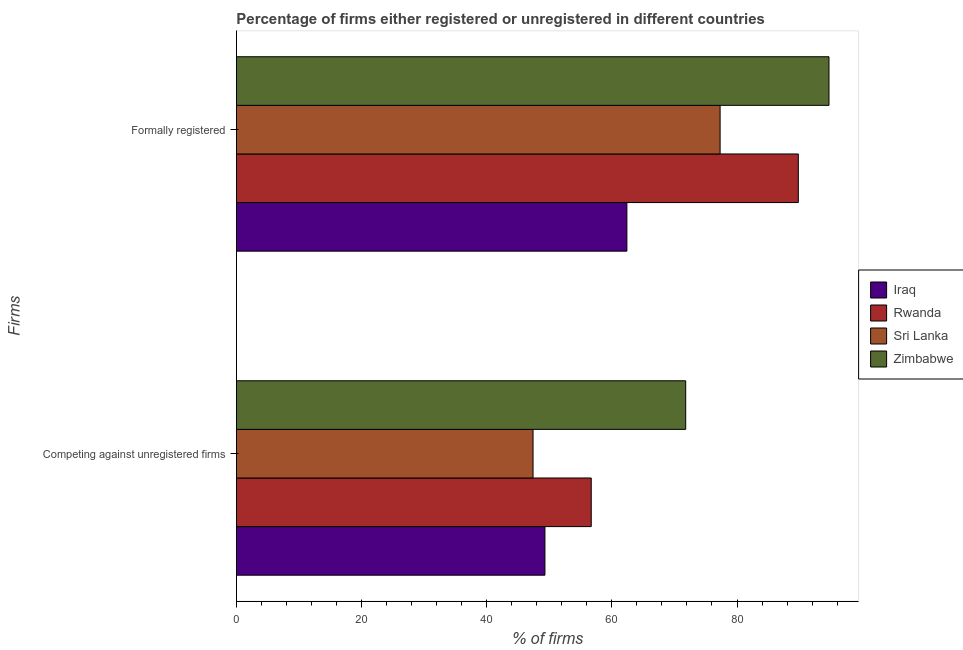How many different coloured bars are there?
Provide a succinct answer. 4. Are the number of bars on each tick of the Y-axis equal?
Your response must be concise. Yes. How many bars are there on the 1st tick from the top?
Your response must be concise. 4. What is the label of the 1st group of bars from the top?
Ensure brevity in your answer.  Formally registered. What is the percentage of formally registered firms in Sri Lanka?
Your answer should be compact. 77.3. Across all countries, what is the maximum percentage of registered firms?
Keep it short and to the point. 71.8. Across all countries, what is the minimum percentage of formally registered firms?
Offer a very short reply. 62.4. In which country was the percentage of formally registered firms maximum?
Make the answer very short. Zimbabwe. In which country was the percentage of formally registered firms minimum?
Make the answer very short. Iraq. What is the total percentage of registered firms in the graph?
Keep it short and to the point. 225.2. What is the difference between the percentage of registered firms in Zimbabwe and that in Rwanda?
Make the answer very short. 15.1. What is the difference between the percentage of registered firms in Rwanda and the percentage of formally registered firms in Zimbabwe?
Your answer should be very brief. -38. What is the average percentage of registered firms per country?
Your response must be concise. 56.3. What is the difference between the percentage of registered firms and percentage of formally registered firms in Sri Lanka?
Offer a very short reply. -29.9. What is the ratio of the percentage of registered firms in Zimbabwe to that in Iraq?
Offer a terse response. 1.46. What does the 3rd bar from the top in Formally registered represents?
Make the answer very short. Rwanda. What does the 2nd bar from the bottom in Competing against unregistered firms represents?
Your response must be concise. Rwanda. How many countries are there in the graph?
Offer a very short reply. 4. Does the graph contain any zero values?
Provide a succinct answer. No. Does the graph contain grids?
Ensure brevity in your answer.  No. How many legend labels are there?
Offer a terse response. 4. How are the legend labels stacked?
Offer a terse response. Vertical. What is the title of the graph?
Provide a succinct answer. Percentage of firms either registered or unregistered in different countries. Does "Bulgaria" appear as one of the legend labels in the graph?
Give a very brief answer. No. What is the label or title of the X-axis?
Your response must be concise. % of firms. What is the label or title of the Y-axis?
Keep it short and to the point. Firms. What is the % of firms in Iraq in Competing against unregistered firms?
Ensure brevity in your answer.  49.3. What is the % of firms in Rwanda in Competing against unregistered firms?
Ensure brevity in your answer.  56.7. What is the % of firms in Sri Lanka in Competing against unregistered firms?
Give a very brief answer. 47.4. What is the % of firms of Zimbabwe in Competing against unregistered firms?
Offer a very short reply. 71.8. What is the % of firms of Iraq in Formally registered?
Ensure brevity in your answer.  62.4. What is the % of firms in Rwanda in Formally registered?
Your response must be concise. 89.8. What is the % of firms in Sri Lanka in Formally registered?
Provide a short and direct response. 77.3. What is the % of firms in Zimbabwe in Formally registered?
Keep it short and to the point. 94.7. Across all Firms, what is the maximum % of firms in Iraq?
Offer a very short reply. 62.4. Across all Firms, what is the maximum % of firms in Rwanda?
Make the answer very short. 89.8. Across all Firms, what is the maximum % of firms of Sri Lanka?
Give a very brief answer. 77.3. Across all Firms, what is the maximum % of firms in Zimbabwe?
Your response must be concise. 94.7. Across all Firms, what is the minimum % of firms of Iraq?
Provide a short and direct response. 49.3. Across all Firms, what is the minimum % of firms in Rwanda?
Your answer should be very brief. 56.7. Across all Firms, what is the minimum % of firms of Sri Lanka?
Your response must be concise. 47.4. Across all Firms, what is the minimum % of firms of Zimbabwe?
Provide a succinct answer. 71.8. What is the total % of firms of Iraq in the graph?
Give a very brief answer. 111.7. What is the total % of firms in Rwanda in the graph?
Offer a very short reply. 146.5. What is the total % of firms in Sri Lanka in the graph?
Provide a succinct answer. 124.7. What is the total % of firms in Zimbabwe in the graph?
Provide a succinct answer. 166.5. What is the difference between the % of firms in Iraq in Competing against unregistered firms and that in Formally registered?
Make the answer very short. -13.1. What is the difference between the % of firms in Rwanda in Competing against unregistered firms and that in Formally registered?
Keep it short and to the point. -33.1. What is the difference between the % of firms of Sri Lanka in Competing against unregistered firms and that in Formally registered?
Keep it short and to the point. -29.9. What is the difference between the % of firms of Zimbabwe in Competing against unregistered firms and that in Formally registered?
Give a very brief answer. -22.9. What is the difference between the % of firms in Iraq in Competing against unregistered firms and the % of firms in Rwanda in Formally registered?
Give a very brief answer. -40.5. What is the difference between the % of firms of Iraq in Competing against unregistered firms and the % of firms of Zimbabwe in Formally registered?
Make the answer very short. -45.4. What is the difference between the % of firms in Rwanda in Competing against unregistered firms and the % of firms in Sri Lanka in Formally registered?
Make the answer very short. -20.6. What is the difference between the % of firms in Rwanda in Competing against unregistered firms and the % of firms in Zimbabwe in Formally registered?
Make the answer very short. -38. What is the difference between the % of firms in Sri Lanka in Competing against unregistered firms and the % of firms in Zimbabwe in Formally registered?
Make the answer very short. -47.3. What is the average % of firms of Iraq per Firms?
Your response must be concise. 55.85. What is the average % of firms in Rwanda per Firms?
Ensure brevity in your answer.  73.25. What is the average % of firms of Sri Lanka per Firms?
Make the answer very short. 62.35. What is the average % of firms of Zimbabwe per Firms?
Your answer should be very brief. 83.25. What is the difference between the % of firms in Iraq and % of firms in Sri Lanka in Competing against unregistered firms?
Offer a very short reply. 1.9. What is the difference between the % of firms in Iraq and % of firms in Zimbabwe in Competing against unregistered firms?
Keep it short and to the point. -22.5. What is the difference between the % of firms in Rwanda and % of firms in Zimbabwe in Competing against unregistered firms?
Provide a succinct answer. -15.1. What is the difference between the % of firms in Sri Lanka and % of firms in Zimbabwe in Competing against unregistered firms?
Keep it short and to the point. -24.4. What is the difference between the % of firms in Iraq and % of firms in Rwanda in Formally registered?
Your answer should be compact. -27.4. What is the difference between the % of firms in Iraq and % of firms in Sri Lanka in Formally registered?
Provide a succinct answer. -14.9. What is the difference between the % of firms of Iraq and % of firms of Zimbabwe in Formally registered?
Provide a short and direct response. -32.3. What is the difference between the % of firms in Sri Lanka and % of firms in Zimbabwe in Formally registered?
Keep it short and to the point. -17.4. What is the ratio of the % of firms in Iraq in Competing against unregistered firms to that in Formally registered?
Offer a very short reply. 0.79. What is the ratio of the % of firms of Rwanda in Competing against unregistered firms to that in Formally registered?
Provide a succinct answer. 0.63. What is the ratio of the % of firms of Sri Lanka in Competing against unregistered firms to that in Formally registered?
Your response must be concise. 0.61. What is the ratio of the % of firms of Zimbabwe in Competing against unregistered firms to that in Formally registered?
Keep it short and to the point. 0.76. What is the difference between the highest and the second highest % of firms in Rwanda?
Your response must be concise. 33.1. What is the difference between the highest and the second highest % of firms in Sri Lanka?
Your answer should be compact. 29.9. What is the difference between the highest and the second highest % of firms of Zimbabwe?
Provide a short and direct response. 22.9. What is the difference between the highest and the lowest % of firms of Iraq?
Make the answer very short. 13.1. What is the difference between the highest and the lowest % of firms of Rwanda?
Give a very brief answer. 33.1. What is the difference between the highest and the lowest % of firms of Sri Lanka?
Ensure brevity in your answer.  29.9. What is the difference between the highest and the lowest % of firms of Zimbabwe?
Keep it short and to the point. 22.9. 